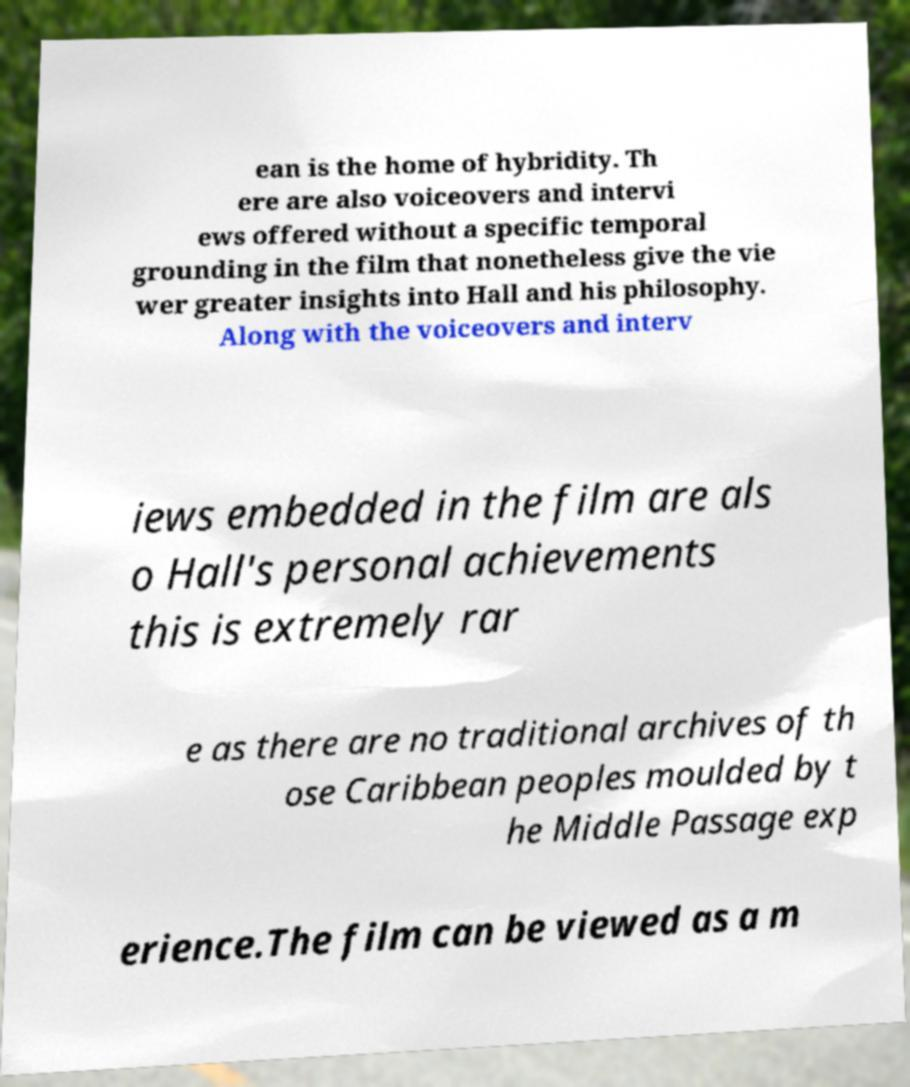I need the written content from this picture converted into text. Can you do that? ean is the home of hybridity. Th ere are also voiceovers and intervi ews offered without a specific temporal grounding in the film that nonetheless give the vie wer greater insights into Hall and his philosophy. Along with the voiceovers and interv iews embedded in the film are als o Hall's personal achievements this is extremely rar e as there are no traditional archives of th ose Caribbean peoples moulded by t he Middle Passage exp erience.The film can be viewed as a m 